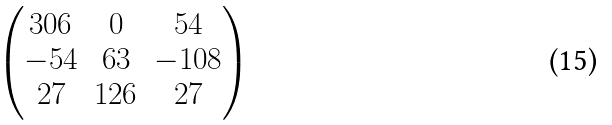Convert formula to latex. <formula><loc_0><loc_0><loc_500><loc_500>\begin{pmatrix} 3 0 6 & 0 & 5 4 \\ - 5 4 & 6 3 & - 1 0 8 \\ 2 7 & 1 2 6 & 2 7 \end{pmatrix}</formula> 